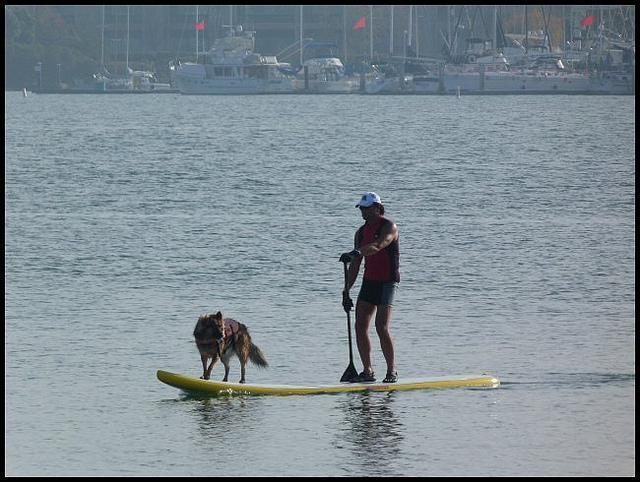How many boats are there?
Give a very brief answer. 2. 